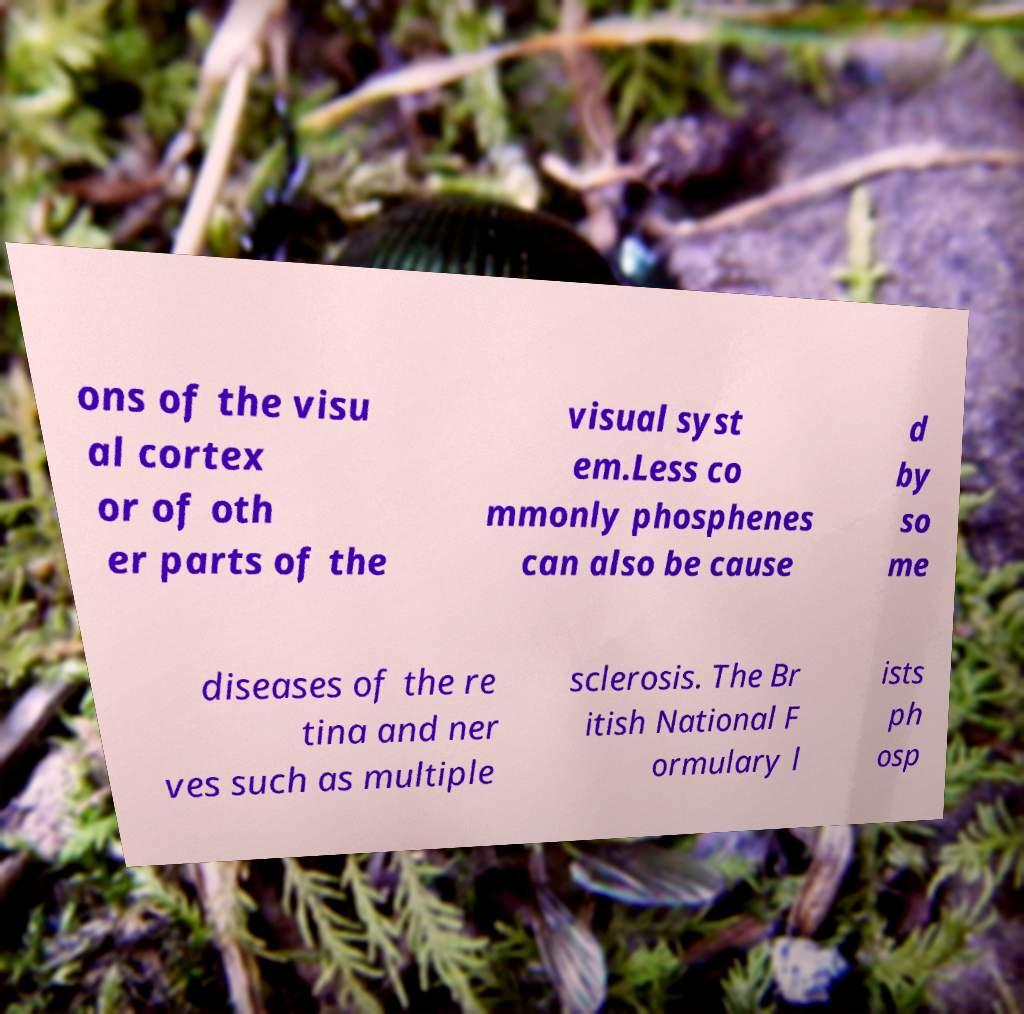Can you read and provide the text displayed in the image?This photo seems to have some interesting text. Can you extract and type it out for me? ons of the visu al cortex or of oth er parts of the visual syst em.Less co mmonly phosphenes can also be cause d by so me diseases of the re tina and ner ves such as multiple sclerosis. The Br itish National F ormulary l ists ph osp 